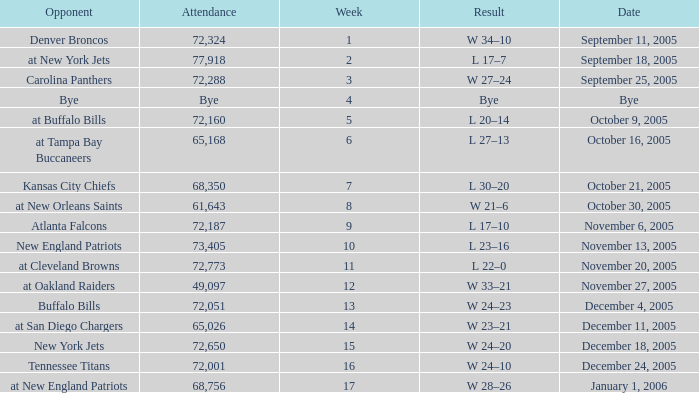What is the Week with a Date of Bye? 1.0. Would you mind parsing the complete table? {'header': ['Opponent', 'Attendance', 'Week', 'Result', 'Date'], 'rows': [['Denver Broncos', '72,324', '1', 'W 34–10', 'September 11, 2005'], ['at New York Jets', '77,918', '2', 'L 17–7', 'September 18, 2005'], ['Carolina Panthers', '72,288', '3', 'W 27–24', 'September 25, 2005'], ['Bye', 'Bye', '4', 'Bye', 'Bye'], ['at Buffalo Bills', '72,160', '5', 'L 20–14', 'October 9, 2005'], ['at Tampa Bay Buccaneers', '65,168', '6', 'L 27–13', 'October 16, 2005'], ['Kansas City Chiefs', '68,350', '7', 'L 30–20', 'October 21, 2005'], ['at New Orleans Saints', '61,643', '8', 'W 21–6', 'October 30, 2005'], ['Atlanta Falcons', '72,187', '9', 'L 17–10', 'November 6, 2005'], ['New England Patriots', '73,405', '10', 'L 23–16', 'November 13, 2005'], ['at Cleveland Browns', '72,773', '11', 'L 22–0', 'November 20, 2005'], ['at Oakland Raiders', '49,097', '12', 'W 33–21', 'November 27, 2005'], ['Buffalo Bills', '72,051', '13', 'W 24–23', 'December 4, 2005'], ['at San Diego Chargers', '65,026', '14', 'W 23–21', 'December 11, 2005'], ['New York Jets', '72,650', '15', 'W 24–20', 'December 18, 2005'], ['Tennessee Titans', '72,001', '16', 'W 24–10', 'December 24, 2005'], ['at New England Patriots', '68,756', '17', 'W 28–26', 'January 1, 2006']]} 